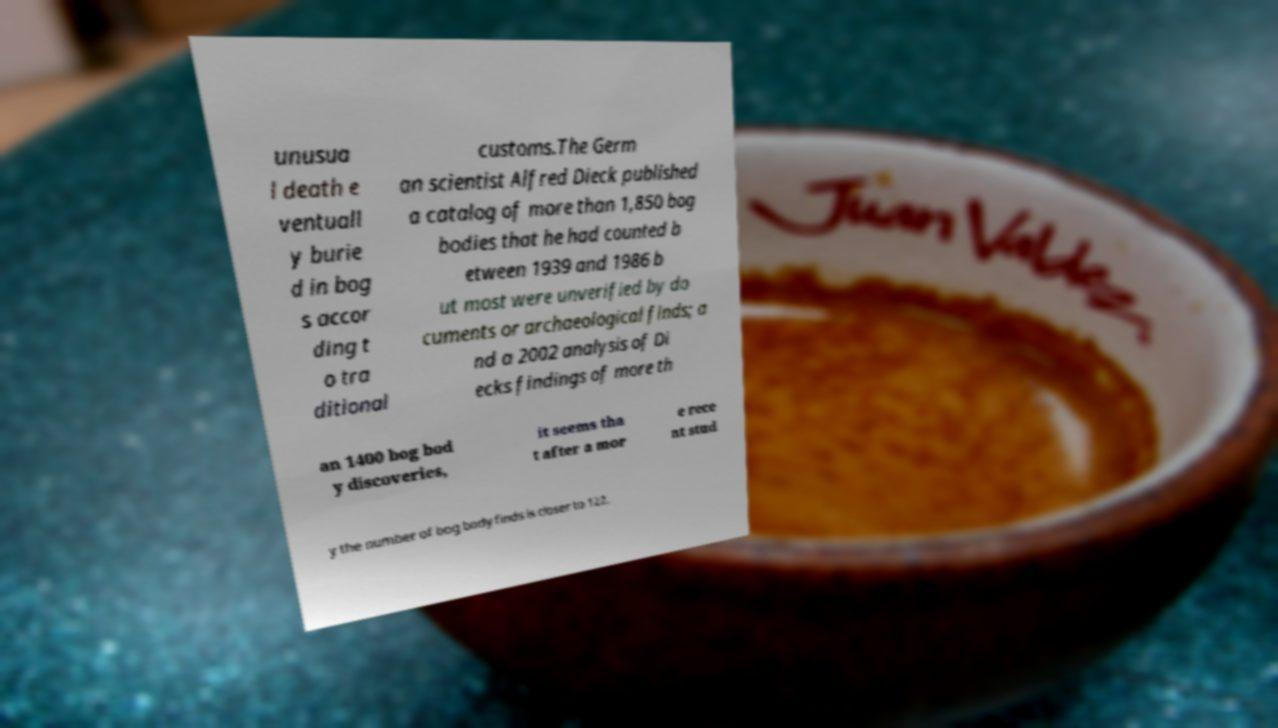Please identify and transcribe the text found in this image. unusua l death e ventuall y burie d in bog s accor ding t o tra ditional customs.The Germ an scientist Alfred Dieck published a catalog of more than 1,850 bog bodies that he had counted b etween 1939 and 1986 b ut most were unverified by do cuments or archaeological finds; a nd a 2002 analysis of Di ecks findings of more th an 1400 bog bod y discoveries, it seems tha t after a mor e rece nt stud y the number of bog body finds is closer to 122. 